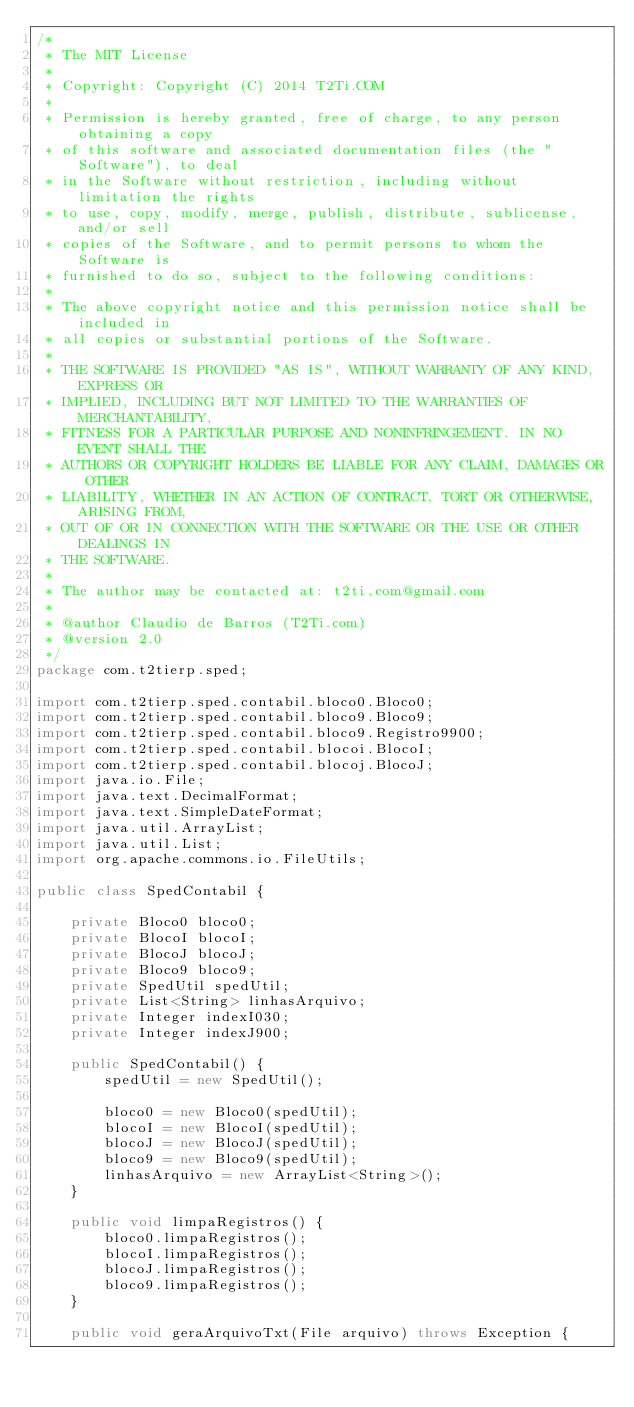<code> <loc_0><loc_0><loc_500><loc_500><_Java_>/*
 * The MIT License
 * 
 * Copyright: Copyright (C) 2014 T2Ti.COM
 * 
 * Permission is hereby granted, free of charge, to any person obtaining a copy
 * of this software and associated documentation files (the "Software"), to deal
 * in the Software without restriction, including without limitation the rights
 * to use, copy, modify, merge, publish, distribute, sublicense, and/or sell
 * copies of the Software, and to permit persons to whom the Software is
 * furnished to do so, subject to the following conditions:
 * 
 * The above copyright notice and this permission notice shall be included in
 * all copies or substantial portions of the Software.
 * 
 * THE SOFTWARE IS PROVIDED "AS IS", WITHOUT WARRANTY OF ANY KIND, EXPRESS OR
 * IMPLIED, INCLUDING BUT NOT LIMITED TO THE WARRANTIES OF MERCHANTABILITY,
 * FITNESS FOR A PARTICULAR PURPOSE AND NONINFRINGEMENT. IN NO EVENT SHALL THE
 * AUTHORS OR COPYRIGHT HOLDERS BE LIABLE FOR ANY CLAIM, DAMAGES OR OTHER
 * LIABILITY, WHETHER IN AN ACTION OF CONTRACT, TORT OR OTHERWISE, ARISING FROM,
 * OUT OF OR IN CONNECTION WITH THE SOFTWARE OR THE USE OR OTHER DEALINGS IN
 * THE SOFTWARE.
 * 
 * The author may be contacted at: t2ti.com@gmail.com
 *
 * @author Claudio de Barros (T2Ti.com)
 * @version 2.0
 */
package com.t2tierp.sped;

import com.t2tierp.sped.contabil.bloco0.Bloco0;
import com.t2tierp.sped.contabil.bloco9.Bloco9;
import com.t2tierp.sped.contabil.bloco9.Registro9900;
import com.t2tierp.sped.contabil.blocoi.BlocoI;
import com.t2tierp.sped.contabil.blocoj.BlocoJ;
import java.io.File;
import java.text.DecimalFormat;
import java.text.SimpleDateFormat;
import java.util.ArrayList;
import java.util.List;
import org.apache.commons.io.FileUtils;

public class SpedContabil {

    private Bloco0 bloco0;
    private BlocoI blocoI;
    private BlocoJ blocoJ;
    private Bloco9 bloco9;
    private SpedUtil spedUtil;
    private List<String> linhasArquivo;
    private Integer indexI030;
    private Integer indexJ900;

    public SpedContabil() {
        spedUtil = new SpedUtil();

        bloco0 = new Bloco0(spedUtil);
        blocoI = new BlocoI(spedUtil);
        blocoJ = new BlocoJ(spedUtil);
        bloco9 = new Bloco9(spedUtil);
        linhasArquivo = new ArrayList<String>();
    }

    public void limpaRegistros() {
        bloco0.limpaRegistros();
        blocoI.limpaRegistros();
        blocoJ.limpaRegistros();
        bloco9.limpaRegistros();
    }

    public void geraArquivoTxt(File arquivo) throws Exception {</code> 